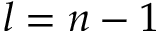Convert formula to latex. <formula><loc_0><loc_0><loc_500><loc_500>l = n - 1</formula> 